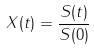<formula> <loc_0><loc_0><loc_500><loc_500>X ( t ) = \frac { S ( t ) } { S ( 0 ) }</formula> 